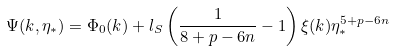<formula> <loc_0><loc_0><loc_500><loc_500>\Psi ( k , \eta _ { * } ) = \Phi _ { 0 } ( k ) + l _ { S } \left ( \frac { 1 } { 8 + p - 6 n } - 1 \right ) \xi ( k ) \eta _ { * } ^ { 5 + p - 6 n }</formula> 